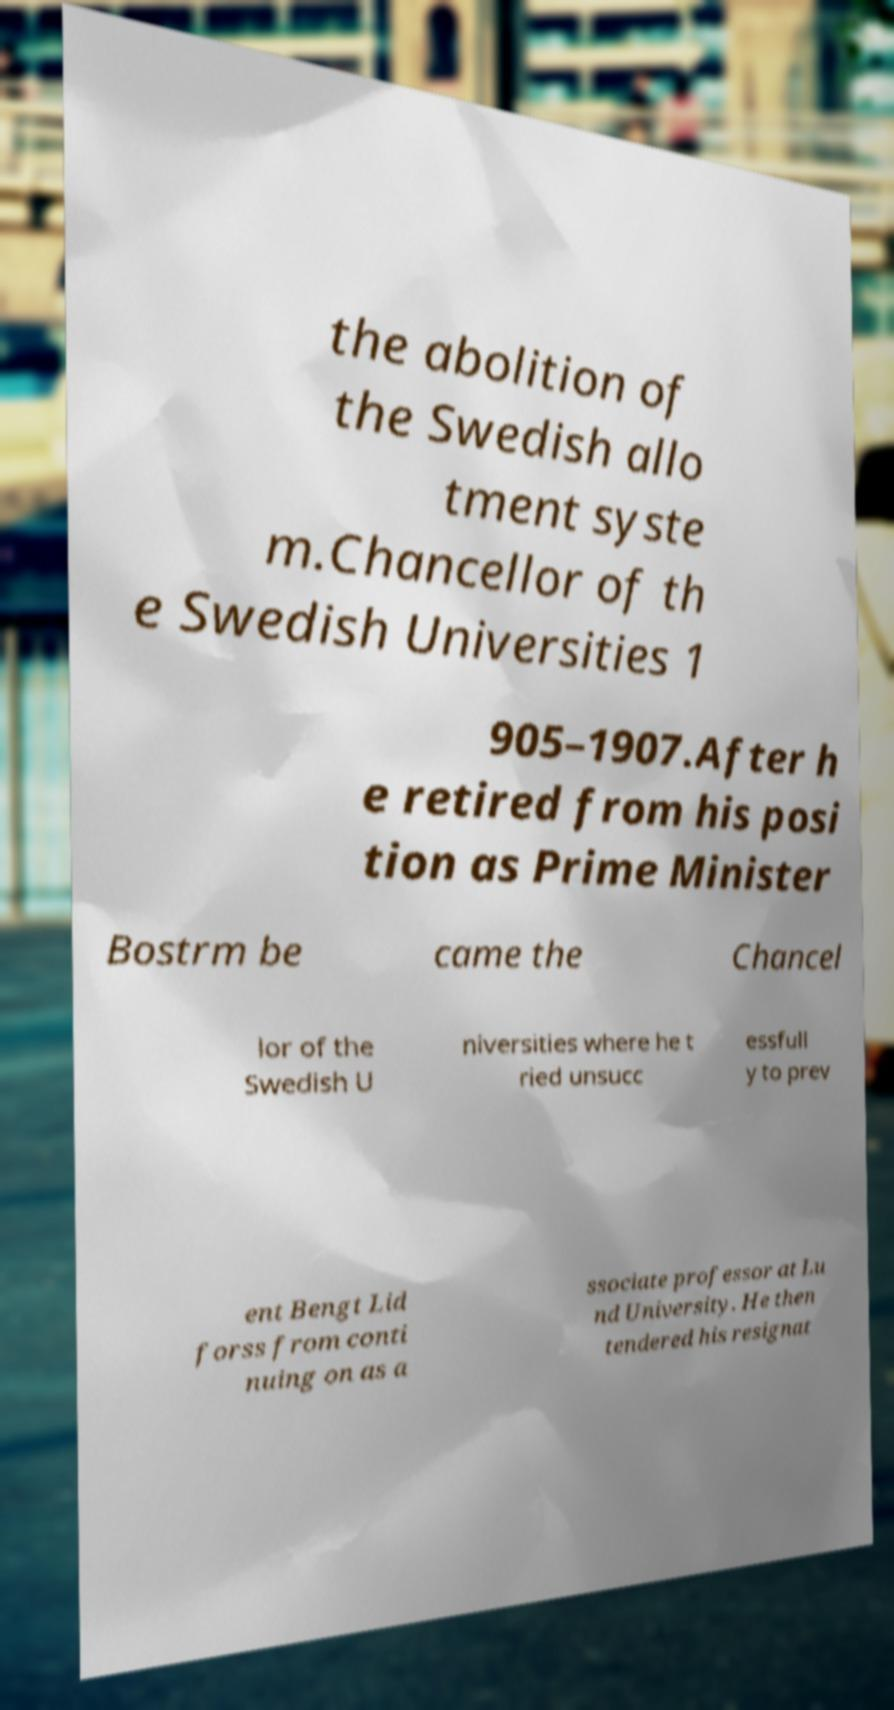There's text embedded in this image that I need extracted. Can you transcribe it verbatim? the abolition of the Swedish allo tment syste m.Chancellor of th e Swedish Universities 1 905–1907.After h e retired from his posi tion as Prime Minister Bostrm be came the Chancel lor of the Swedish U niversities where he t ried unsucc essfull y to prev ent Bengt Lid forss from conti nuing on as a ssociate professor at Lu nd University. He then tendered his resignat 